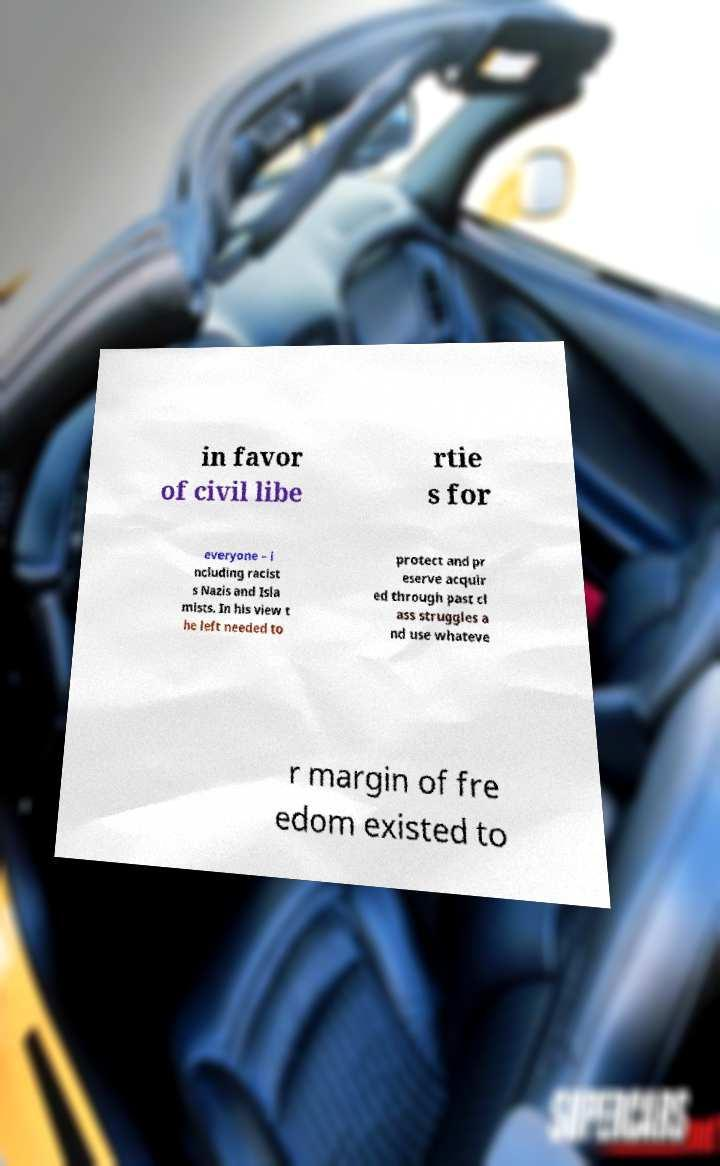For documentation purposes, I need the text within this image transcribed. Could you provide that? in favor of civil libe rtie s for everyone – i ncluding racist s Nazis and Isla mists. In his view t he left needed to protect and pr eserve acquir ed through past cl ass struggles a nd use whateve r margin of fre edom existed to 